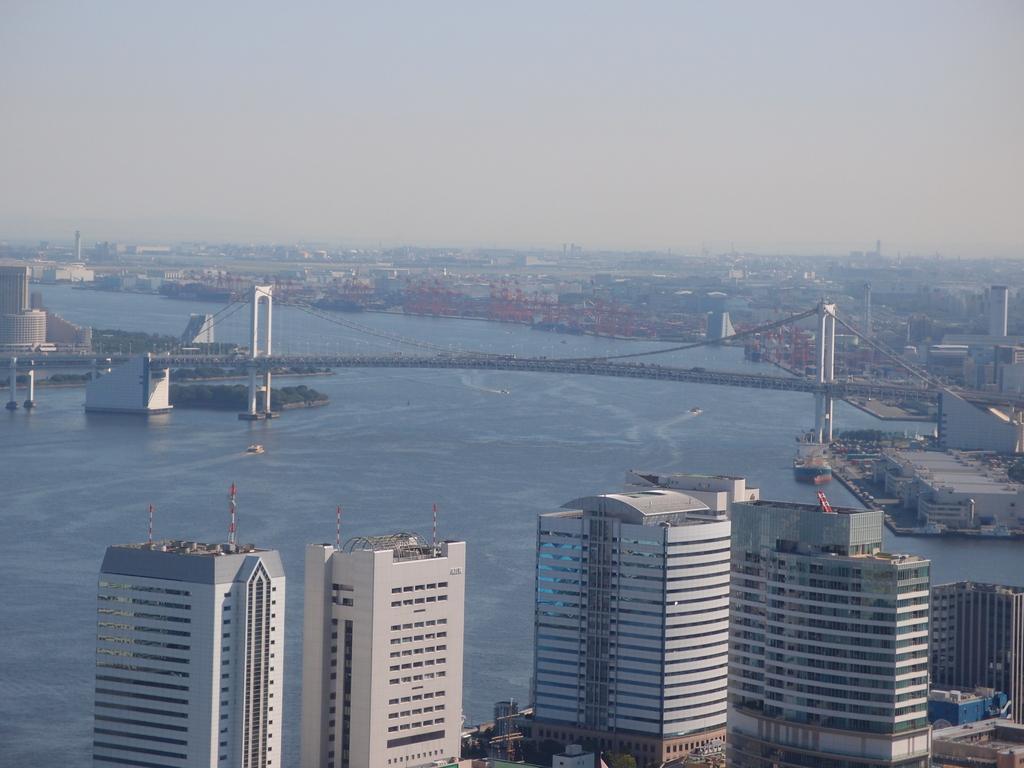In one or two sentences, can you explain what this image depicts? Here we can see buildings. Background there is a bridge and water. 